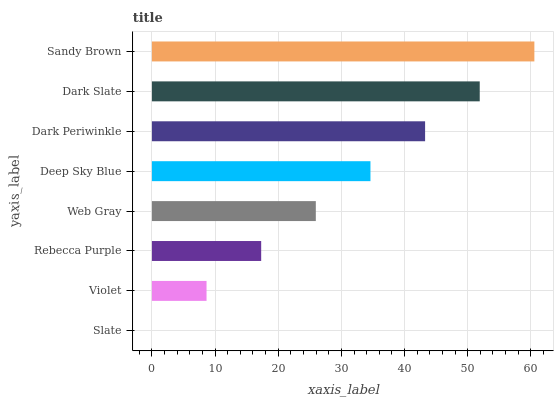Is Slate the minimum?
Answer yes or no. Yes. Is Sandy Brown the maximum?
Answer yes or no. Yes. Is Violet the minimum?
Answer yes or no. No. Is Violet the maximum?
Answer yes or no. No. Is Violet greater than Slate?
Answer yes or no. Yes. Is Slate less than Violet?
Answer yes or no. Yes. Is Slate greater than Violet?
Answer yes or no. No. Is Violet less than Slate?
Answer yes or no. No. Is Deep Sky Blue the high median?
Answer yes or no. Yes. Is Web Gray the low median?
Answer yes or no. Yes. Is Violet the high median?
Answer yes or no. No. Is Sandy Brown the low median?
Answer yes or no. No. 